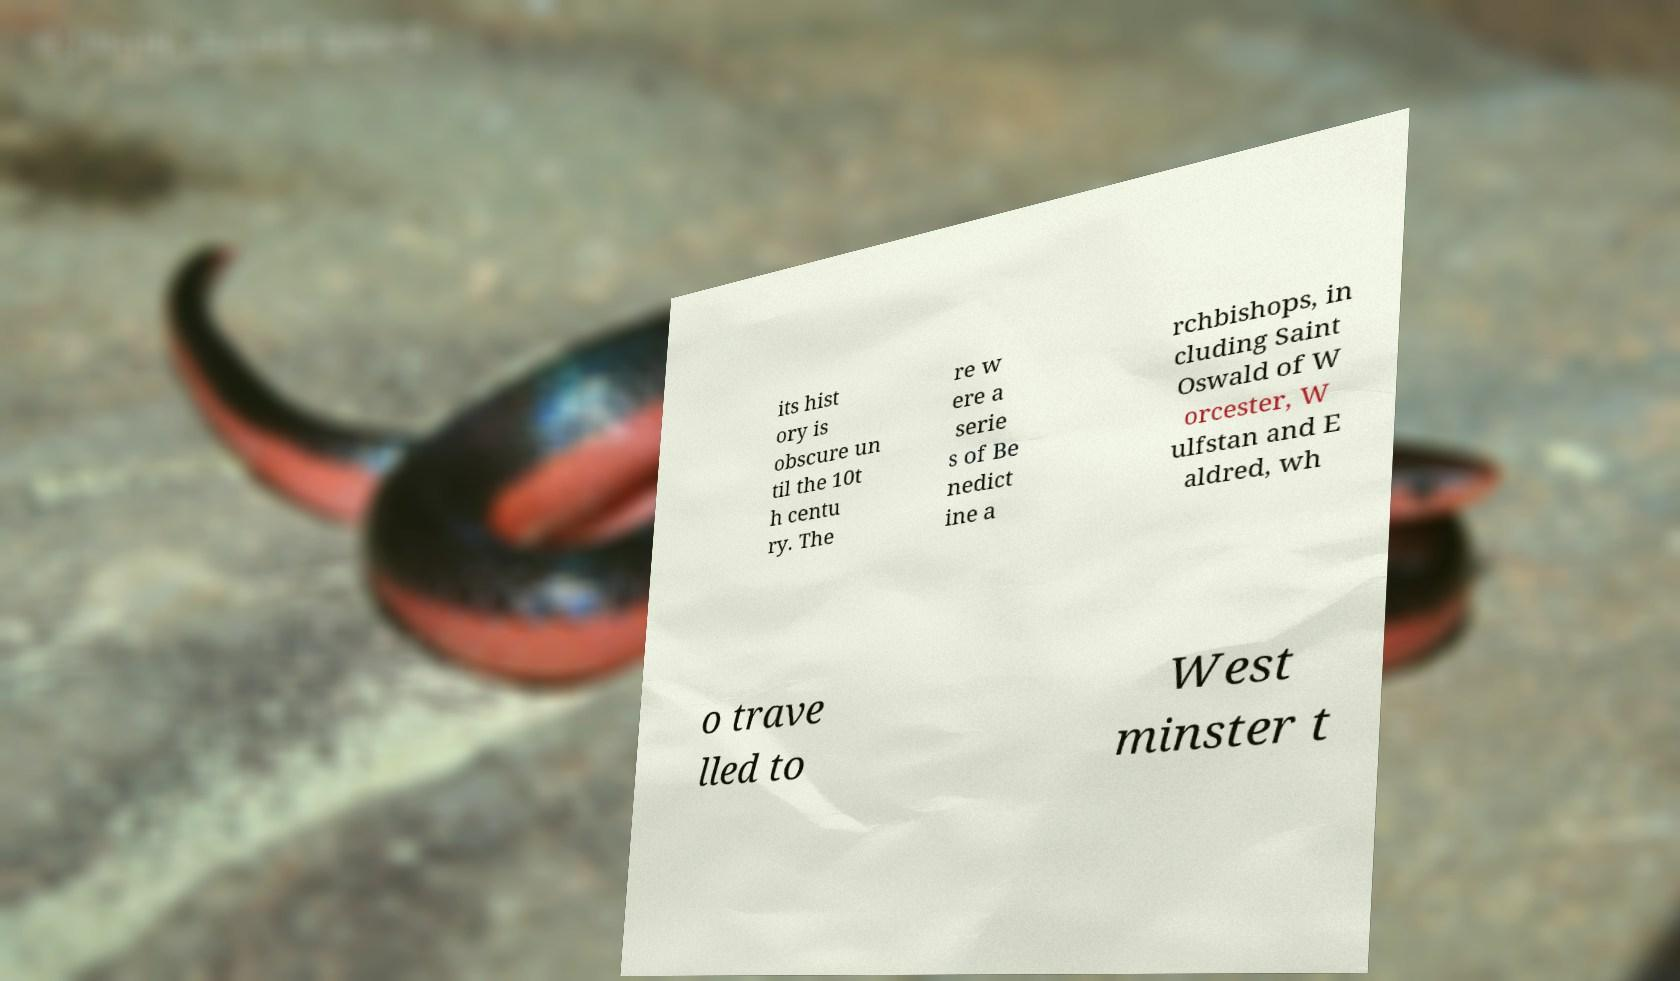Can you read and provide the text displayed in the image?This photo seems to have some interesting text. Can you extract and type it out for me? its hist ory is obscure un til the 10t h centu ry. The re w ere a serie s of Be nedict ine a rchbishops, in cluding Saint Oswald of W orcester, W ulfstan and E aldred, wh o trave lled to West minster t 